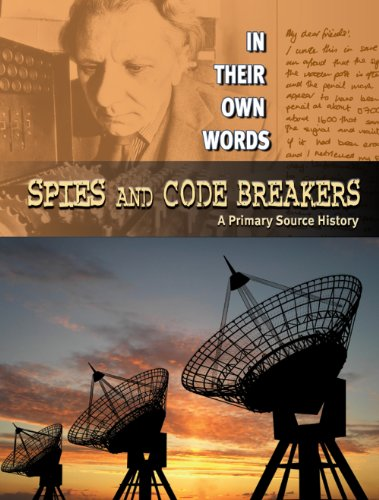Can you explain the significance of the imagery used on the cover? The cover images, featuring a historical figure and radar antennas with a sunset in the background, symbolize the era of technological advancement in espionage and communication interception during wartime. 